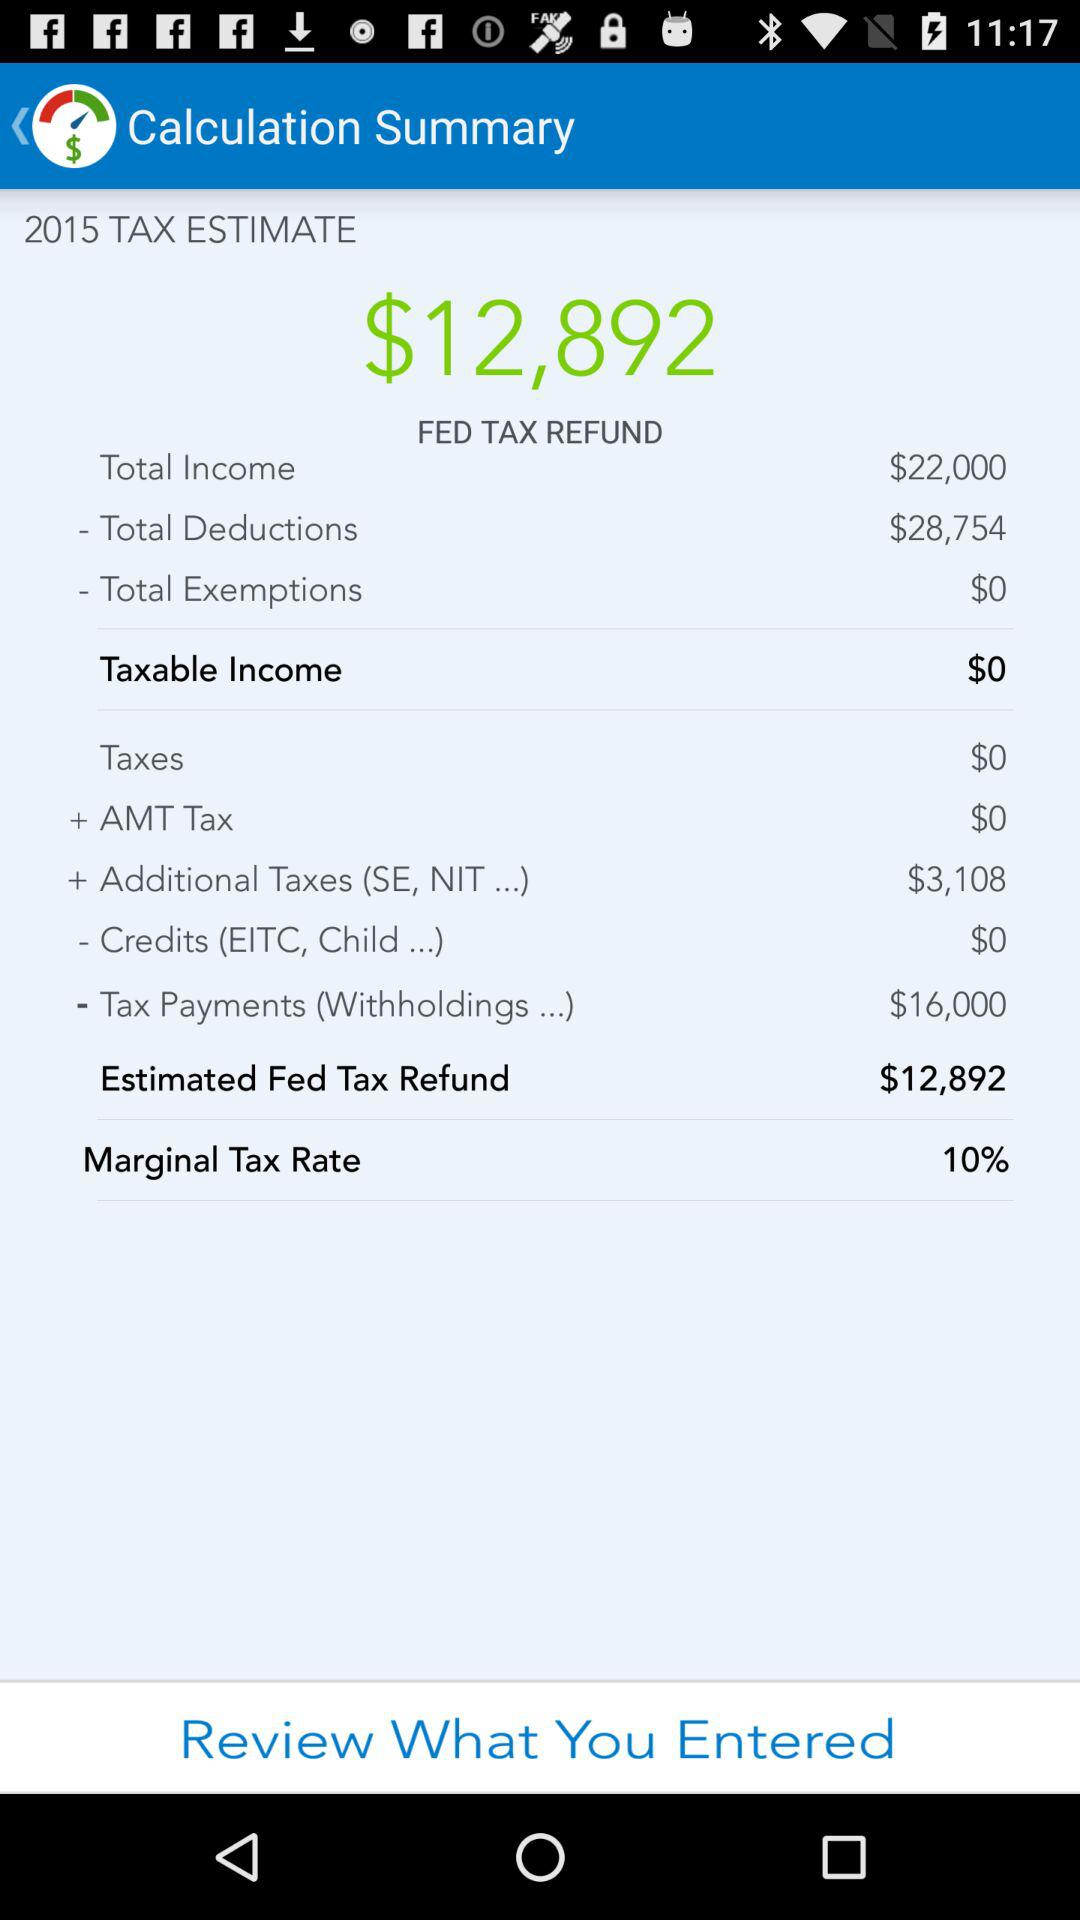What is the total income? The total income is $22,000. 